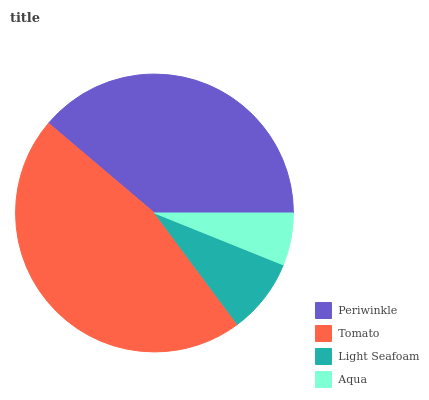Is Aqua the minimum?
Answer yes or no. Yes. Is Tomato the maximum?
Answer yes or no. Yes. Is Light Seafoam the minimum?
Answer yes or no. No. Is Light Seafoam the maximum?
Answer yes or no. No. Is Tomato greater than Light Seafoam?
Answer yes or no. Yes. Is Light Seafoam less than Tomato?
Answer yes or no. Yes. Is Light Seafoam greater than Tomato?
Answer yes or no. No. Is Tomato less than Light Seafoam?
Answer yes or no. No. Is Periwinkle the high median?
Answer yes or no. Yes. Is Light Seafoam the low median?
Answer yes or no. Yes. Is Aqua the high median?
Answer yes or no. No. Is Aqua the low median?
Answer yes or no. No. 